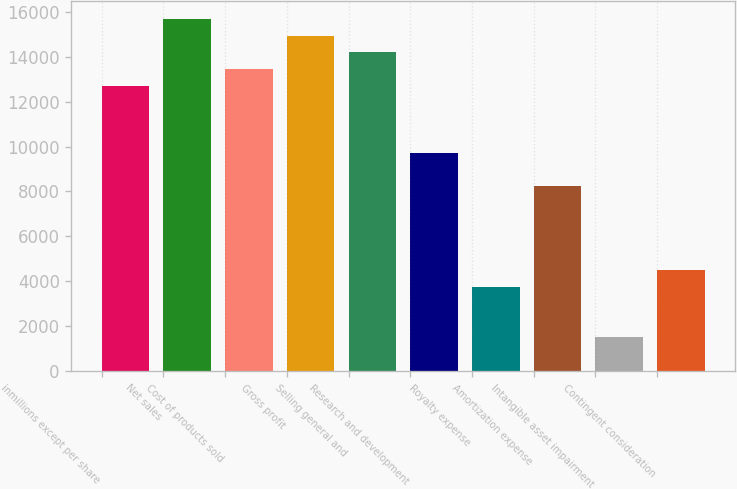Convert chart to OTSL. <chart><loc_0><loc_0><loc_500><loc_500><bar_chart><fcel>inmillions except per share<fcel>Net sales<fcel>Cost of products sold<fcel>Gross profit<fcel>Selling general and<fcel>Research and development<fcel>Royalty expense<fcel>Amortization expense<fcel>Intangible asset impairment<fcel>Contingent consideration<nl><fcel>12710.7<fcel>15701.5<fcel>13458.4<fcel>14953.8<fcel>14206.1<fcel>9720.02<fcel>3738.58<fcel>8224.66<fcel>1495.54<fcel>4486.26<nl></chart> 